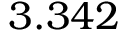Convert formula to latex. <formula><loc_0><loc_0><loc_500><loc_500>3 . 3 4 2</formula> 